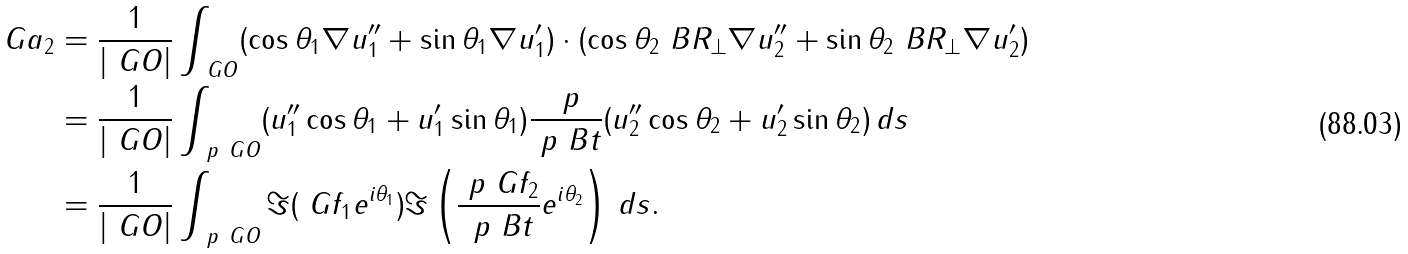Convert formula to latex. <formula><loc_0><loc_0><loc_500><loc_500>\ G a _ { 2 } & = \frac { 1 } { | \ G O | } \int _ { \ G O } ( \cos \theta _ { 1 } \nabla u _ { 1 } ^ { \prime \prime } + \sin \theta _ { 1 } \nabla u _ { 1 } ^ { \prime } ) \cdot ( \cos \theta _ { 2 } \ B R _ { \perp } \nabla u _ { 2 } ^ { \prime \prime } + \sin \theta _ { 2 } \ B R _ { \perp } \nabla u _ { 2 } ^ { \prime } ) \\ & = \frac { 1 } { | \ G O | } \int _ { \ p \ G O } ( u _ { 1 } ^ { \prime \prime } \cos \theta _ { 1 } + u _ { 1 } ^ { \prime } \sin \theta _ { 1 } ) \frac { \ p } { \ p \ B t } ( u _ { 2 } ^ { \prime \prime } \cos \theta _ { 2 } + u _ { 2 } ^ { \prime } \sin \theta _ { 2 } ) \, d s \\ & = \frac { 1 } { | \ G O | } \int _ { \ p \ G O } \Im ( \ G f _ { 1 } e ^ { i \theta _ { 1 } } ) \Im \left ( \frac { \ p \ G f _ { 2 } } { \ p \ B t } e ^ { i \theta _ { 2 } } \right ) \, d s .</formula> 